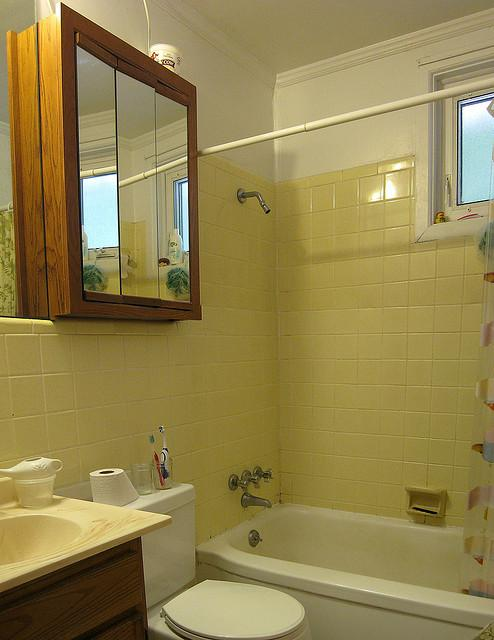Why is the toilet paper on the toilet tank? Please explain your reasoning. no holder. There isn't any other place to put it. 